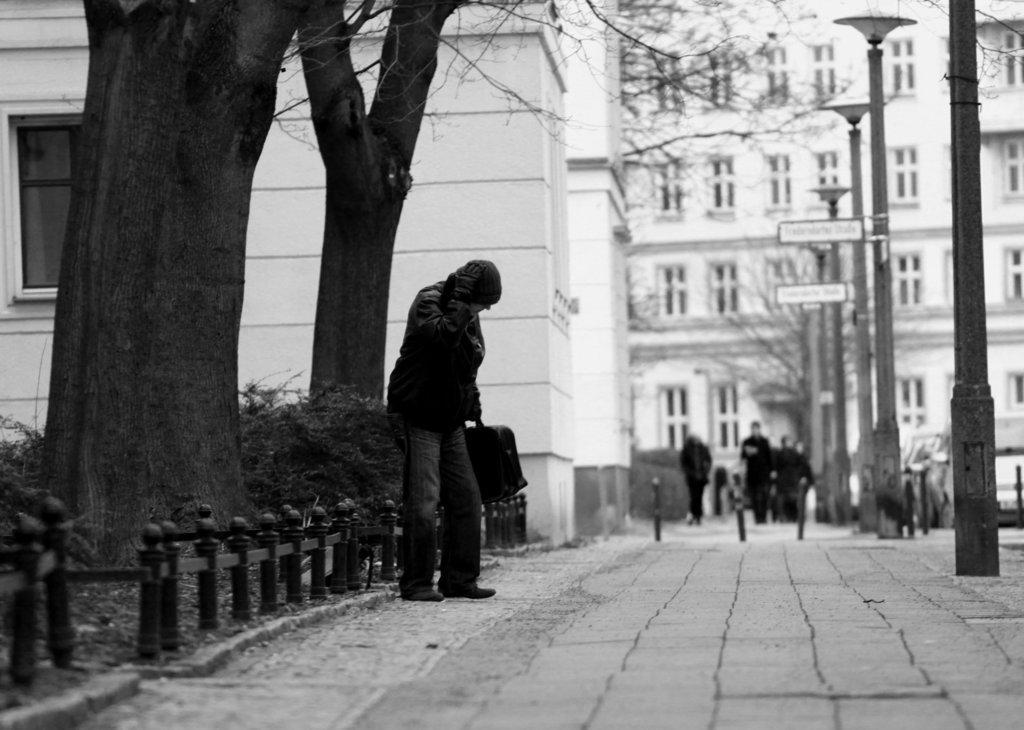Can you describe this image briefly? In this image we can see black and white picture of the group of people on the ground. One person is standing and holding a bag in his hand, we can also see some poles, boards with some text and some trees. On the right side of the image we can see some vehicles parked on the ground. In the background, we can see buildings with windows. 